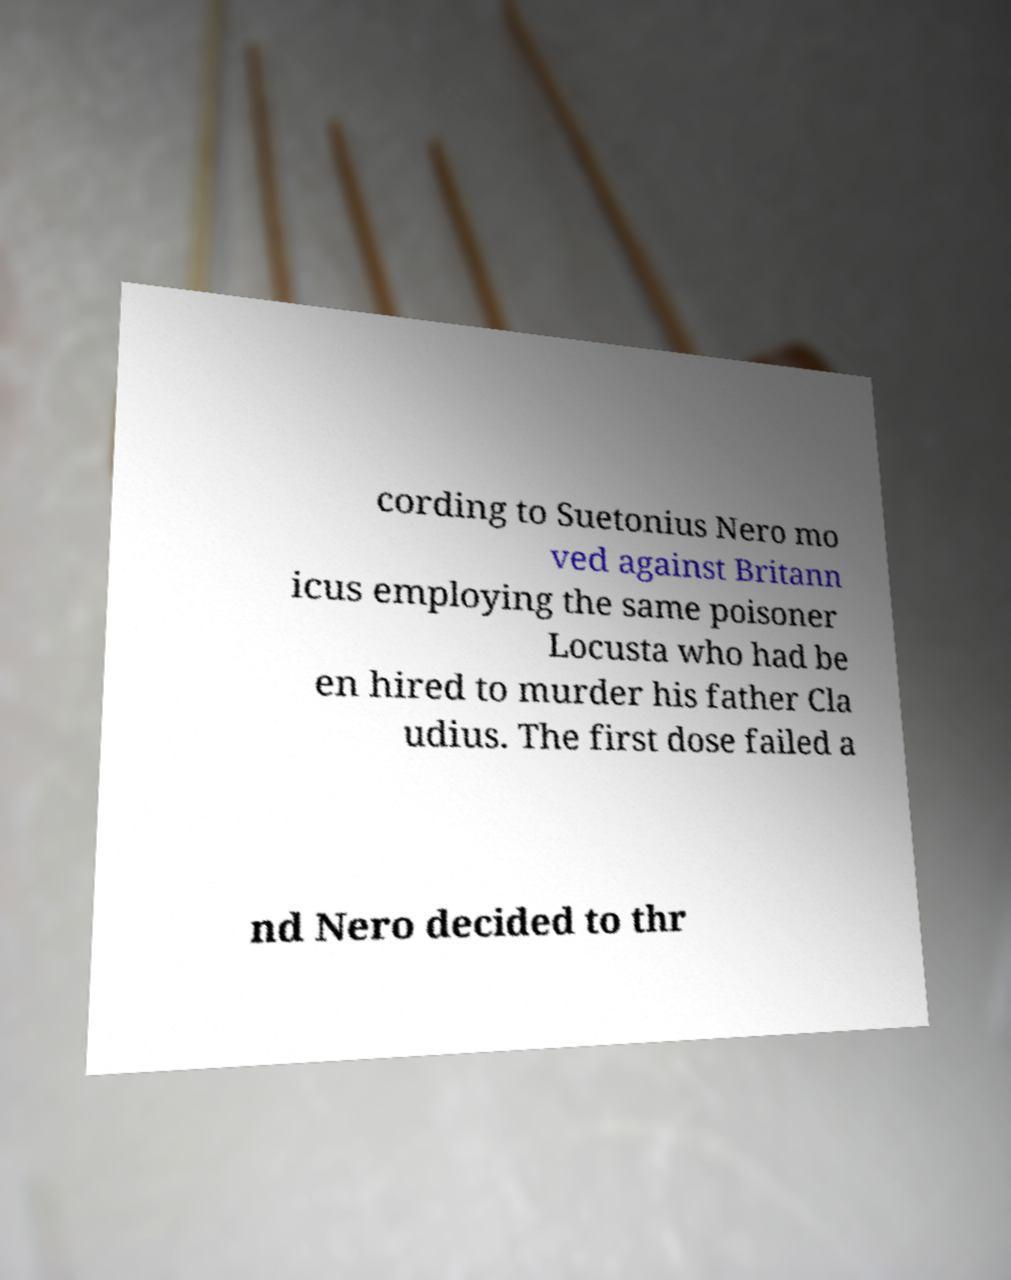For documentation purposes, I need the text within this image transcribed. Could you provide that? cording to Suetonius Nero mo ved against Britann icus employing the same poisoner Locusta who had be en hired to murder his father Cla udius. The first dose failed a nd Nero decided to thr 